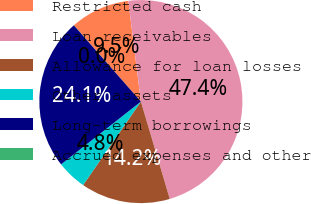Convert chart to OTSL. <chart><loc_0><loc_0><loc_500><loc_500><pie_chart><fcel>Restricted cash<fcel>Loan receivables<fcel>Allowance for loan losses<fcel>Other assets<fcel>Long-term borrowings<fcel>Accrued expenses and other<nl><fcel>9.49%<fcel>47.39%<fcel>14.23%<fcel>4.75%<fcel>24.13%<fcel>0.01%<nl></chart> 